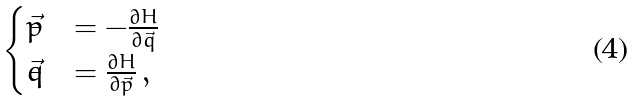Convert formula to latex. <formula><loc_0><loc_0><loc_500><loc_500>\begin{cases} \dot { \vec { p } } & = - \frac { \partial H } { \partial \vec { q } } \\ \dot { \vec { q } } & = \frac { \partial H } { \partial \vec { p } } \, , \end{cases}</formula> 